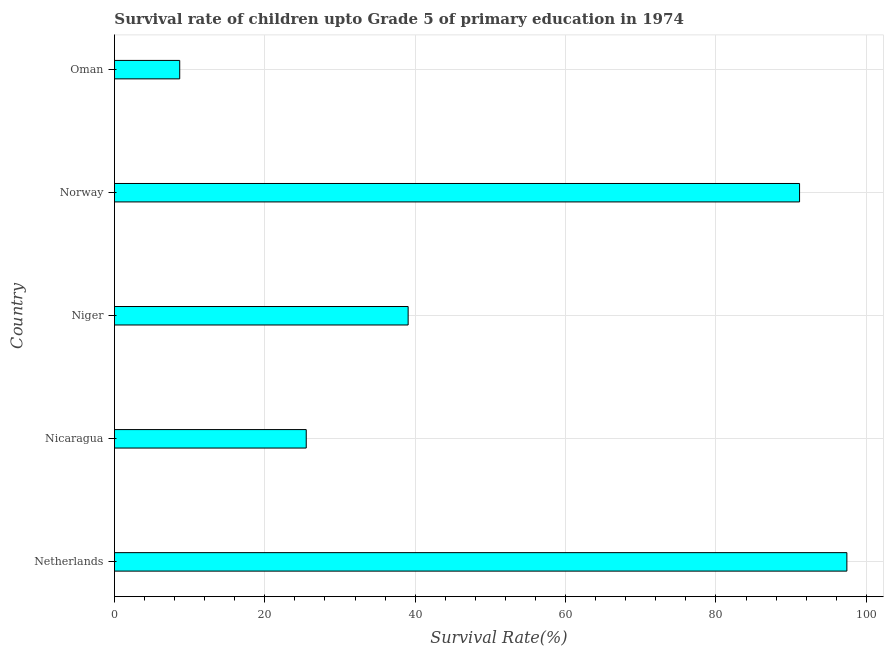Does the graph contain any zero values?
Offer a very short reply. No. What is the title of the graph?
Provide a succinct answer. Survival rate of children upto Grade 5 of primary education in 1974 . What is the label or title of the X-axis?
Make the answer very short. Survival Rate(%). What is the label or title of the Y-axis?
Your answer should be compact. Country. What is the survival rate in Niger?
Keep it short and to the point. 39.06. Across all countries, what is the maximum survival rate?
Give a very brief answer. 97.41. Across all countries, what is the minimum survival rate?
Keep it short and to the point. 8.68. In which country was the survival rate maximum?
Keep it short and to the point. Netherlands. In which country was the survival rate minimum?
Give a very brief answer. Oman. What is the sum of the survival rate?
Your answer should be compact. 261.79. What is the difference between the survival rate in Niger and Norway?
Your answer should be compact. -52.06. What is the average survival rate per country?
Offer a very short reply. 52.36. What is the median survival rate?
Offer a very short reply. 39.06. In how many countries, is the survival rate greater than 4 %?
Provide a succinct answer. 5. What is the ratio of the survival rate in Netherlands to that in Norway?
Keep it short and to the point. 1.07. What is the difference between the highest and the second highest survival rate?
Keep it short and to the point. 6.29. What is the difference between the highest and the lowest survival rate?
Your response must be concise. 88.73. How many bars are there?
Your answer should be compact. 5. Are all the bars in the graph horizontal?
Your response must be concise. Yes. What is the difference between two consecutive major ticks on the X-axis?
Give a very brief answer. 20. What is the Survival Rate(%) of Netherlands?
Your answer should be very brief. 97.41. What is the Survival Rate(%) in Nicaragua?
Your response must be concise. 25.51. What is the Survival Rate(%) of Niger?
Ensure brevity in your answer.  39.06. What is the Survival Rate(%) of Norway?
Ensure brevity in your answer.  91.12. What is the Survival Rate(%) of Oman?
Make the answer very short. 8.68. What is the difference between the Survival Rate(%) in Netherlands and Nicaragua?
Your response must be concise. 71.9. What is the difference between the Survival Rate(%) in Netherlands and Niger?
Your answer should be compact. 58.35. What is the difference between the Survival Rate(%) in Netherlands and Norway?
Your answer should be very brief. 6.29. What is the difference between the Survival Rate(%) in Netherlands and Oman?
Offer a terse response. 88.73. What is the difference between the Survival Rate(%) in Nicaragua and Niger?
Keep it short and to the point. -13.55. What is the difference between the Survival Rate(%) in Nicaragua and Norway?
Provide a succinct answer. -65.61. What is the difference between the Survival Rate(%) in Nicaragua and Oman?
Your answer should be compact. 16.83. What is the difference between the Survival Rate(%) in Niger and Norway?
Provide a short and direct response. -52.06. What is the difference between the Survival Rate(%) in Niger and Oman?
Make the answer very short. 30.38. What is the difference between the Survival Rate(%) in Norway and Oman?
Provide a short and direct response. 82.44. What is the ratio of the Survival Rate(%) in Netherlands to that in Nicaragua?
Provide a succinct answer. 3.82. What is the ratio of the Survival Rate(%) in Netherlands to that in Niger?
Offer a terse response. 2.49. What is the ratio of the Survival Rate(%) in Netherlands to that in Norway?
Offer a very short reply. 1.07. What is the ratio of the Survival Rate(%) in Netherlands to that in Oman?
Make the answer very short. 11.22. What is the ratio of the Survival Rate(%) in Nicaragua to that in Niger?
Your answer should be compact. 0.65. What is the ratio of the Survival Rate(%) in Nicaragua to that in Norway?
Your answer should be very brief. 0.28. What is the ratio of the Survival Rate(%) in Nicaragua to that in Oman?
Offer a terse response. 2.94. What is the ratio of the Survival Rate(%) in Niger to that in Norway?
Offer a very short reply. 0.43. What is the ratio of the Survival Rate(%) in Niger to that in Oman?
Keep it short and to the point. 4.5. What is the ratio of the Survival Rate(%) in Norway to that in Oman?
Make the answer very short. 10.49. 